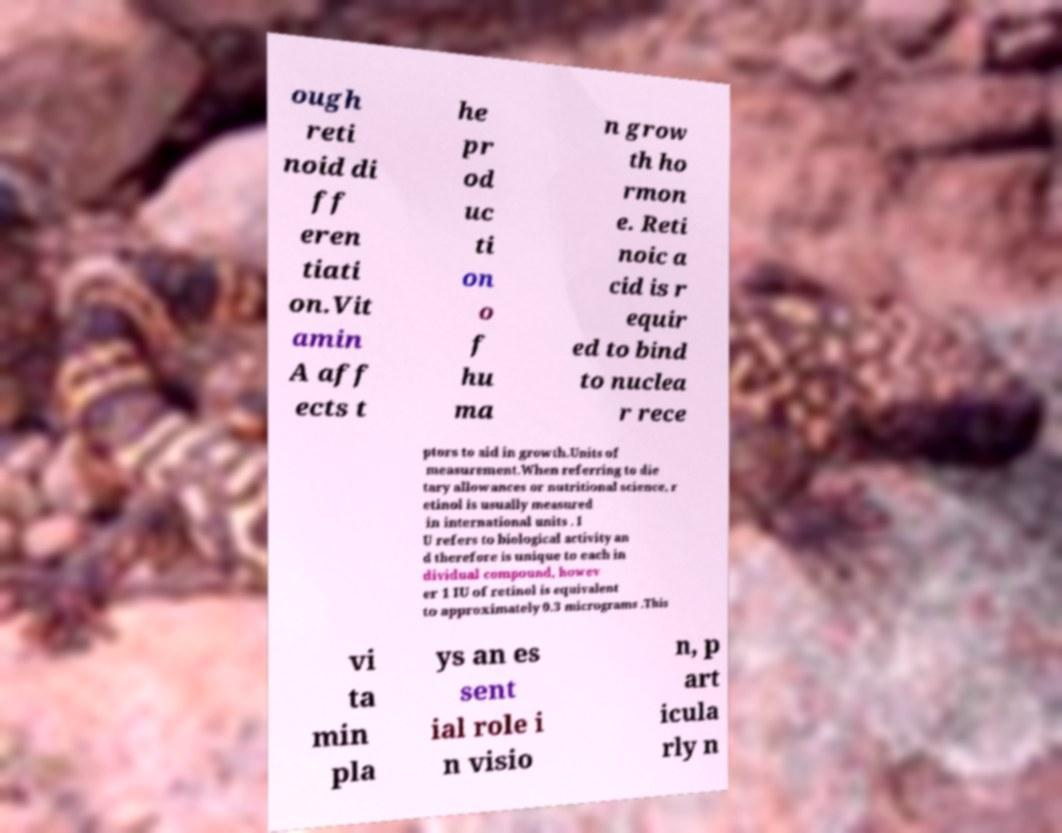Could you assist in decoding the text presented in this image and type it out clearly? ough reti noid di ff eren tiati on.Vit amin A aff ects t he pr od uc ti on o f hu ma n grow th ho rmon e. Reti noic a cid is r equir ed to bind to nuclea r rece ptors to aid in growth.Units of measurement.When referring to die tary allowances or nutritional science, r etinol is usually measured in international units . I U refers to biological activity an d therefore is unique to each in dividual compound, howev er 1 IU of retinol is equivalent to approximately 0.3 micrograms .This vi ta min pla ys an es sent ial role i n visio n, p art icula rly n 